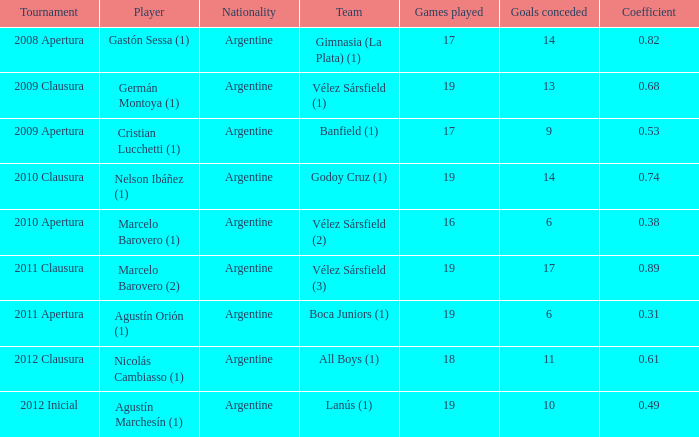How many nationalities are there for the 2011 apertura? 1.0. 